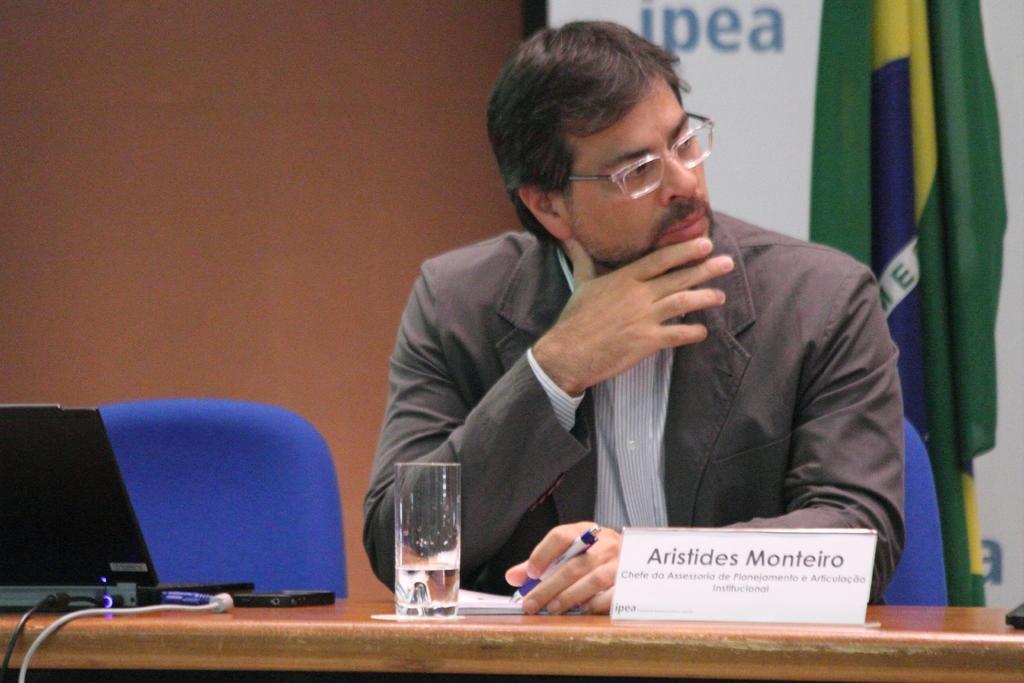In one or two sentences, can you explain what this image depicts? In this picture I can see a man sitting on the chair and holding a pen. I can see a laptop, mobile, cables, glass and a nameplate on the table. I can see a flag, board , and in the background there is wall. 